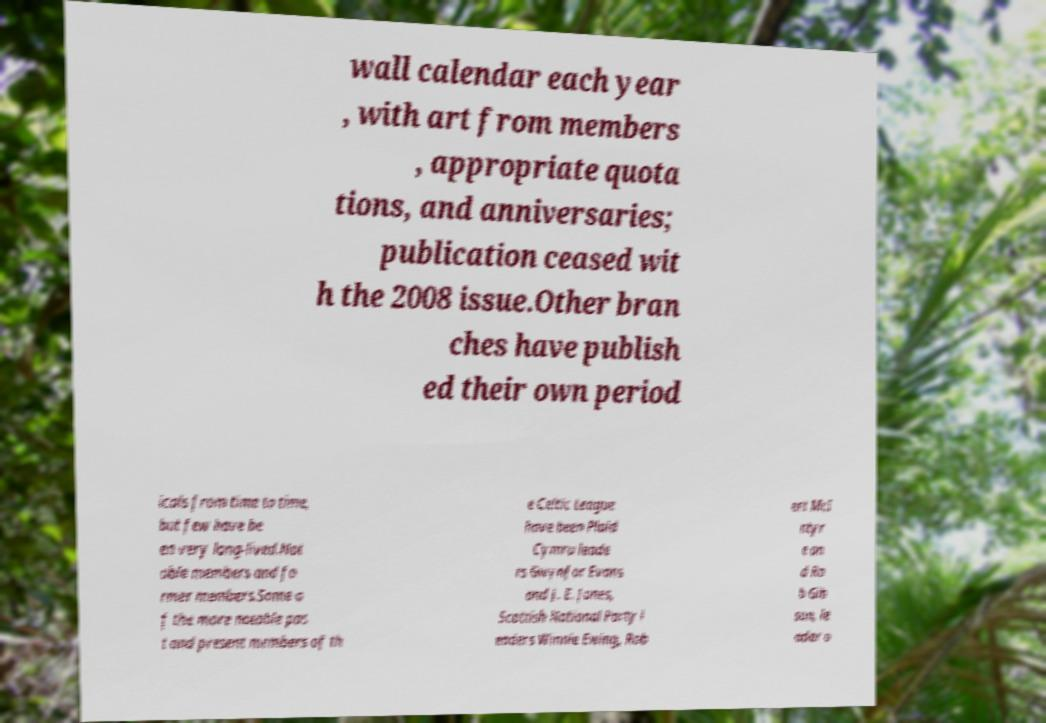What messages or text are displayed in this image? I need them in a readable, typed format. wall calendar each year , with art from members , appropriate quota tions, and anniversaries; publication ceased wit h the 2008 issue.Other bran ches have publish ed their own period icals from time to time, but few have be en very long-lived.Not able members and fo rmer members.Some o f the more notable pas t and present members of th e Celtic League have been Plaid Cymru leade rs Gwynfor Evans and J. E. Jones, Scottish National Party l eaders Winnie Ewing, Rob ert McI ntyr e an d Ro b Gib son, le ader o 